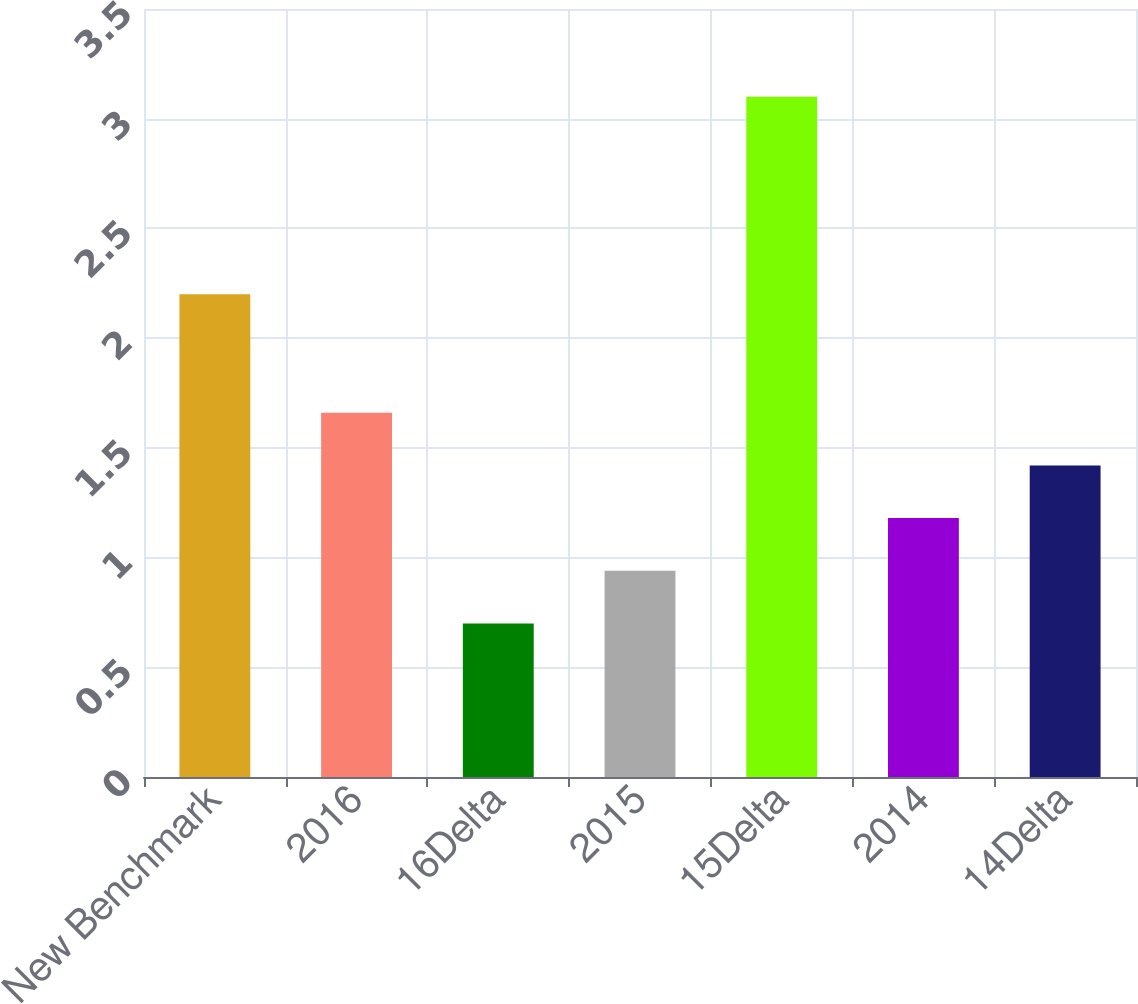Convert chart. <chart><loc_0><loc_0><loc_500><loc_500><bar_chart><fcel>New Benchmark<fcel>2016<fcel>16Delta<fcel>2015<fcel>15Delta<fcel>2014<fcel>14Delta<nl><fcel>2.2<fcel>1.66<fcel>0.7<fcel>0.94<fcel>3.1<fcel>1.18<fcel>1.42<nl></chart> 